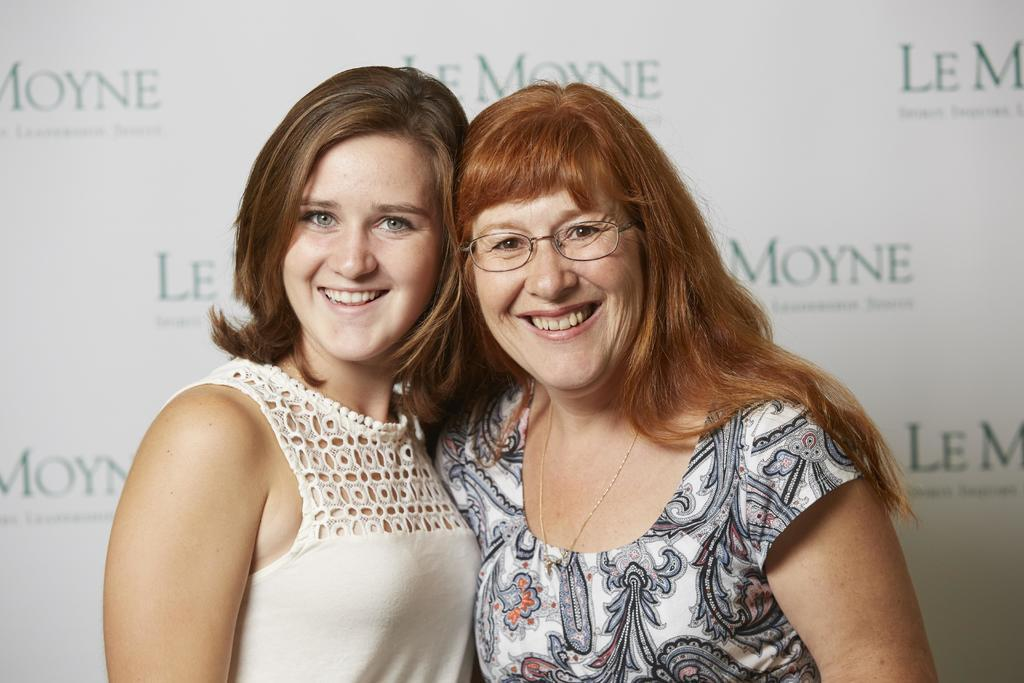How many people are in the image? There are two women in the image. What is in the background of the image? There is a white color board in the background of the image. What is written on the white color board? Text is written on the white color board. What type of gate can be seen in the image? There is no gate present in the image. What afterthought is expressed by the women in the image? The image does not convey any afterthoughts or expressions from the women. What belief is shared by the women in the image? The image does not provide any information about the beliefs of the women. 